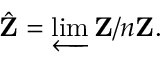<formula> <loc_0><loc_0><loc_500><loc_500>{ \hat { Z } } = \varprojlim Z / n Z .</formula> 